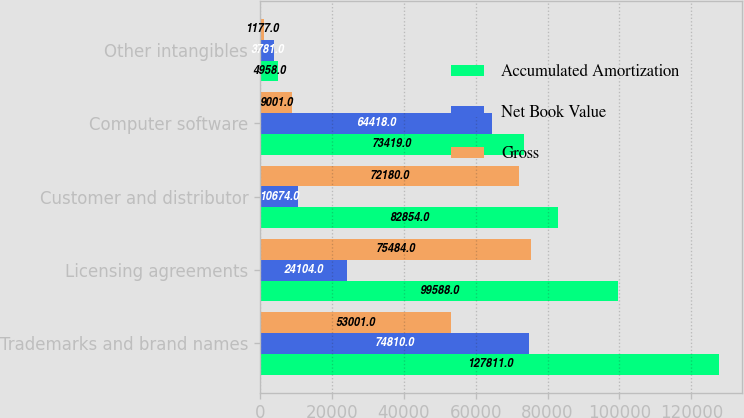<chart> <loc_0><loc_0><loc_500><loc_500><stacked_bar_chart><ecel><fcel>Trademarks and brand names<fcel>Licensing agreements<fcel>Customer and distributor<fcel>Computer software<fcel>Other intangibles<nl><fcel>Accumulated Amortization<fcel>127811<fcel>99588<fcel>82854<fcel>73419<fcel>4958<nl><fcel>Net Book Value<fcel>74810<fcel>24104<fcel>10674<fcel>64418<fcel>3781<nl><fcel>Gross<fcel>53001<fcel>75484<fcel>72180<fcel>9001<fcel>1177<nl></chart> 